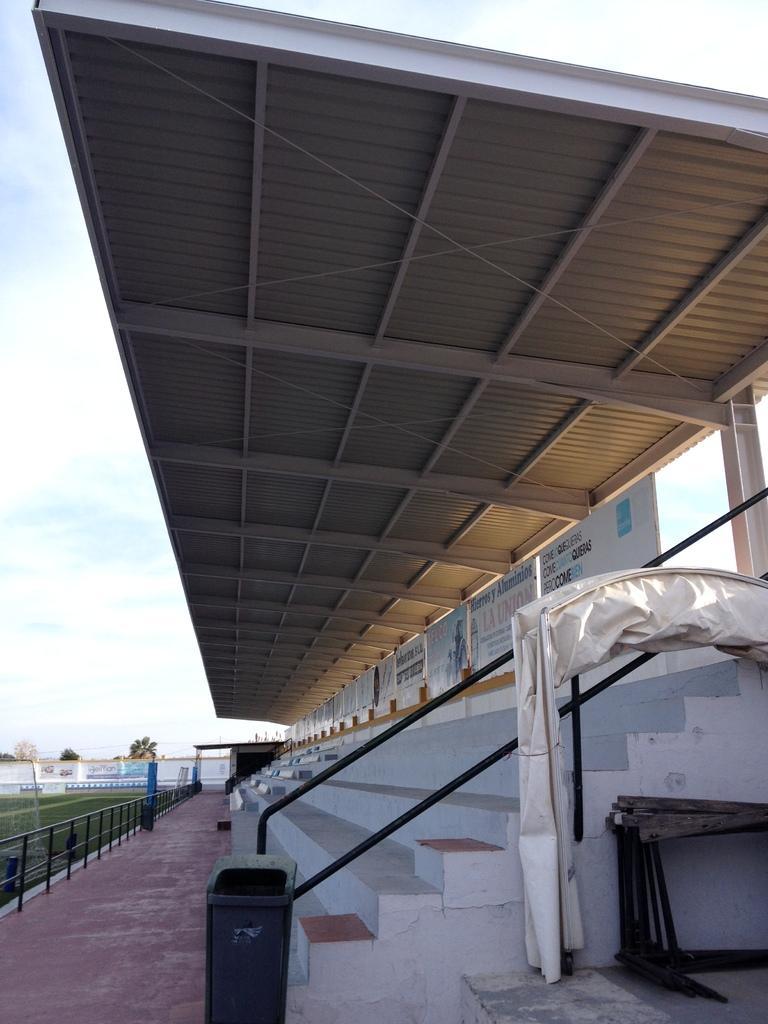How would you summarize this image in a sentence or two? In this picture we can see the audience sitting area made from iron shed frame and down we can see some step. Beside we can see black color dustbin. In the front we can see some fencing grill and a grass field. 